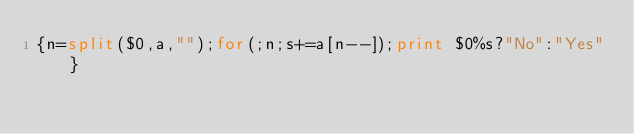Convert code to text. <code><loc_0><loc_0><loc_500><loc_500><_Awk_>{n=split($0,a,"");for(;n;s+=a[n--]);print $0%s?"No":"Yes"}</code> 